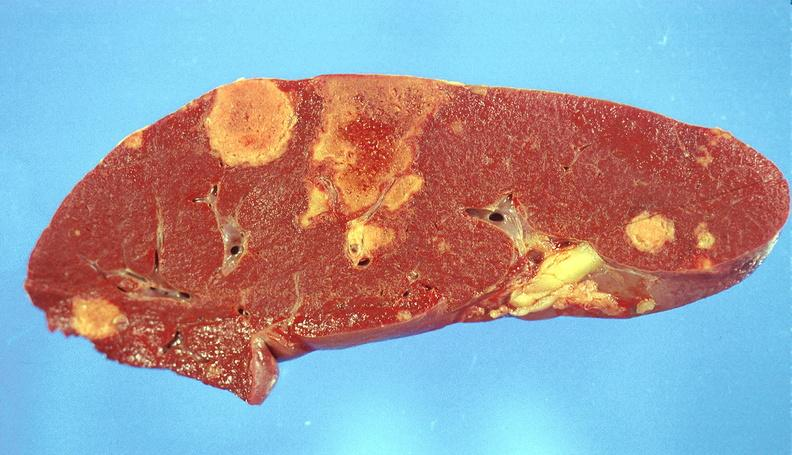what does this image show?
Answer the question using a single word or phrase. Splenic infarcts 